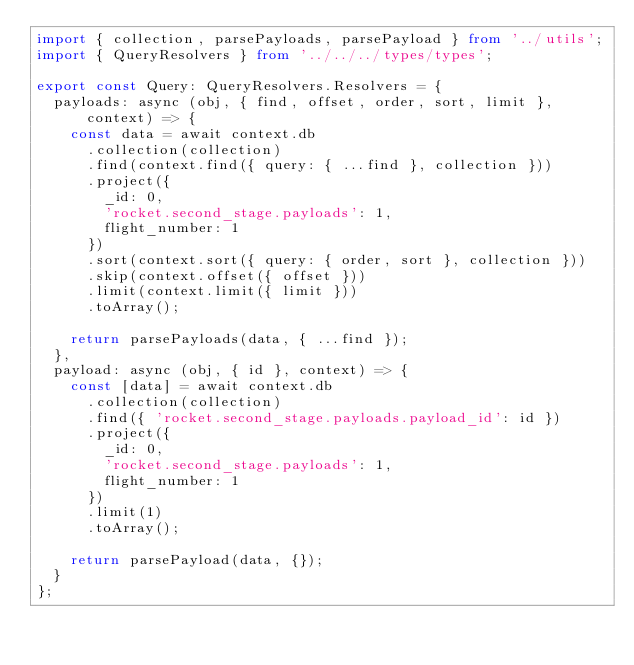Convert code to text. <code><loc_0><loc_0><loc_500><loc_500><_TypeScript_>import { collection, parsePayloads, parsePayload } from '../utils';
import { QueryResolvers } from '../../../types/types';

export const Query: QueryResolvers.Resolvers = {
  payloads: async (obj, { find, offset, order, sort, limit }, context) => {
    const data = await context.db
      .collection(collection)
      .find(context.find({ query: { ...find }, collection }))
      .project({
        _id: 0,
        'rocket.second_stage.payloads': 1,
        flight_number: 1
      })
      .sort(context.sort({ query: { order, sort }, collection }))
      .skip(context.offset({ offset }))
      .limit(context.limit({ limit }))
      .toArray();

    return parsePayloads(data, { ...find });
  },
  payload: async (obj, { id }, context) => {
    const [data] = await context.db
      .collection(collection)
      .find({ 'rocket.second_stage.payloads.payload_id': id })
      .project({
        _id: 0,
        'rocket.second_stage.payloads': 1,
        flight_number: 1
      })
      .limit(1)
      .toArray();

    return parsePayload(data, {});
  }
};
</code> 